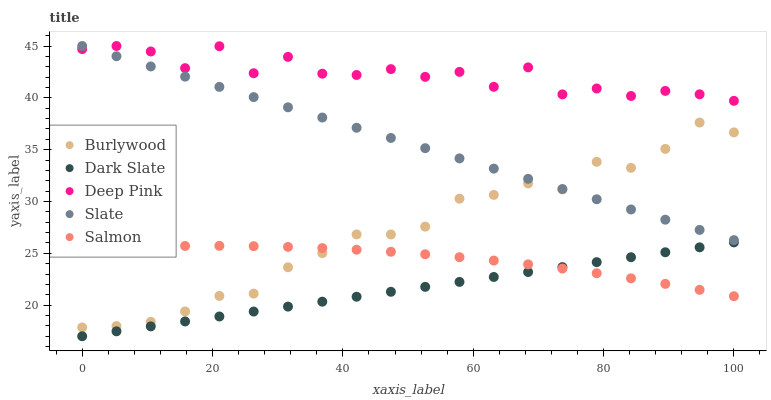Does Dark Slate have the minimum area under the curve?
Answer yes or no. Yes. Does Deep Pink have the maximum area under the curve?
Answer yes or no. Yes. Does Slate have the minimum area under the curve?
Answer yes or no. No. Does Slate have the maximum area under the curve?
Answer yes or no. No. Is Dark Slate the smoothest?
Answer yes or no. Yes. Is Deep Pink the roughest?
Answer yes or no. Yes. Is Slate the smoothest?
Answer yes or no. No. Is Slate the roughest?
Answer yes or no. No. Does Dark Slate have the lowest value?
Answer yes or no. Yes. Does Slate have the lowest value?
Answer yes or no. No. Does Deep Pink have the highest value?
Answer yes or no. Yes. Does Dark Slate have the highest value?
Answer yes or no. No. Is Dark Slate less than Deep Pink?
Answer yes or no. Yes. Is Slate greater than Dark Slate?
Answer yes or no. Yes. Does Slate intersect Deep Pink?
Answer yes or no. Yes. Is Slate less than Deep Pink?
Answer yes or no. No. Is Slate greater than Deep Pink?
Answer yes or no. No. Does Dark Slate intersect Deep Pink?
Answer yes or no. No. 